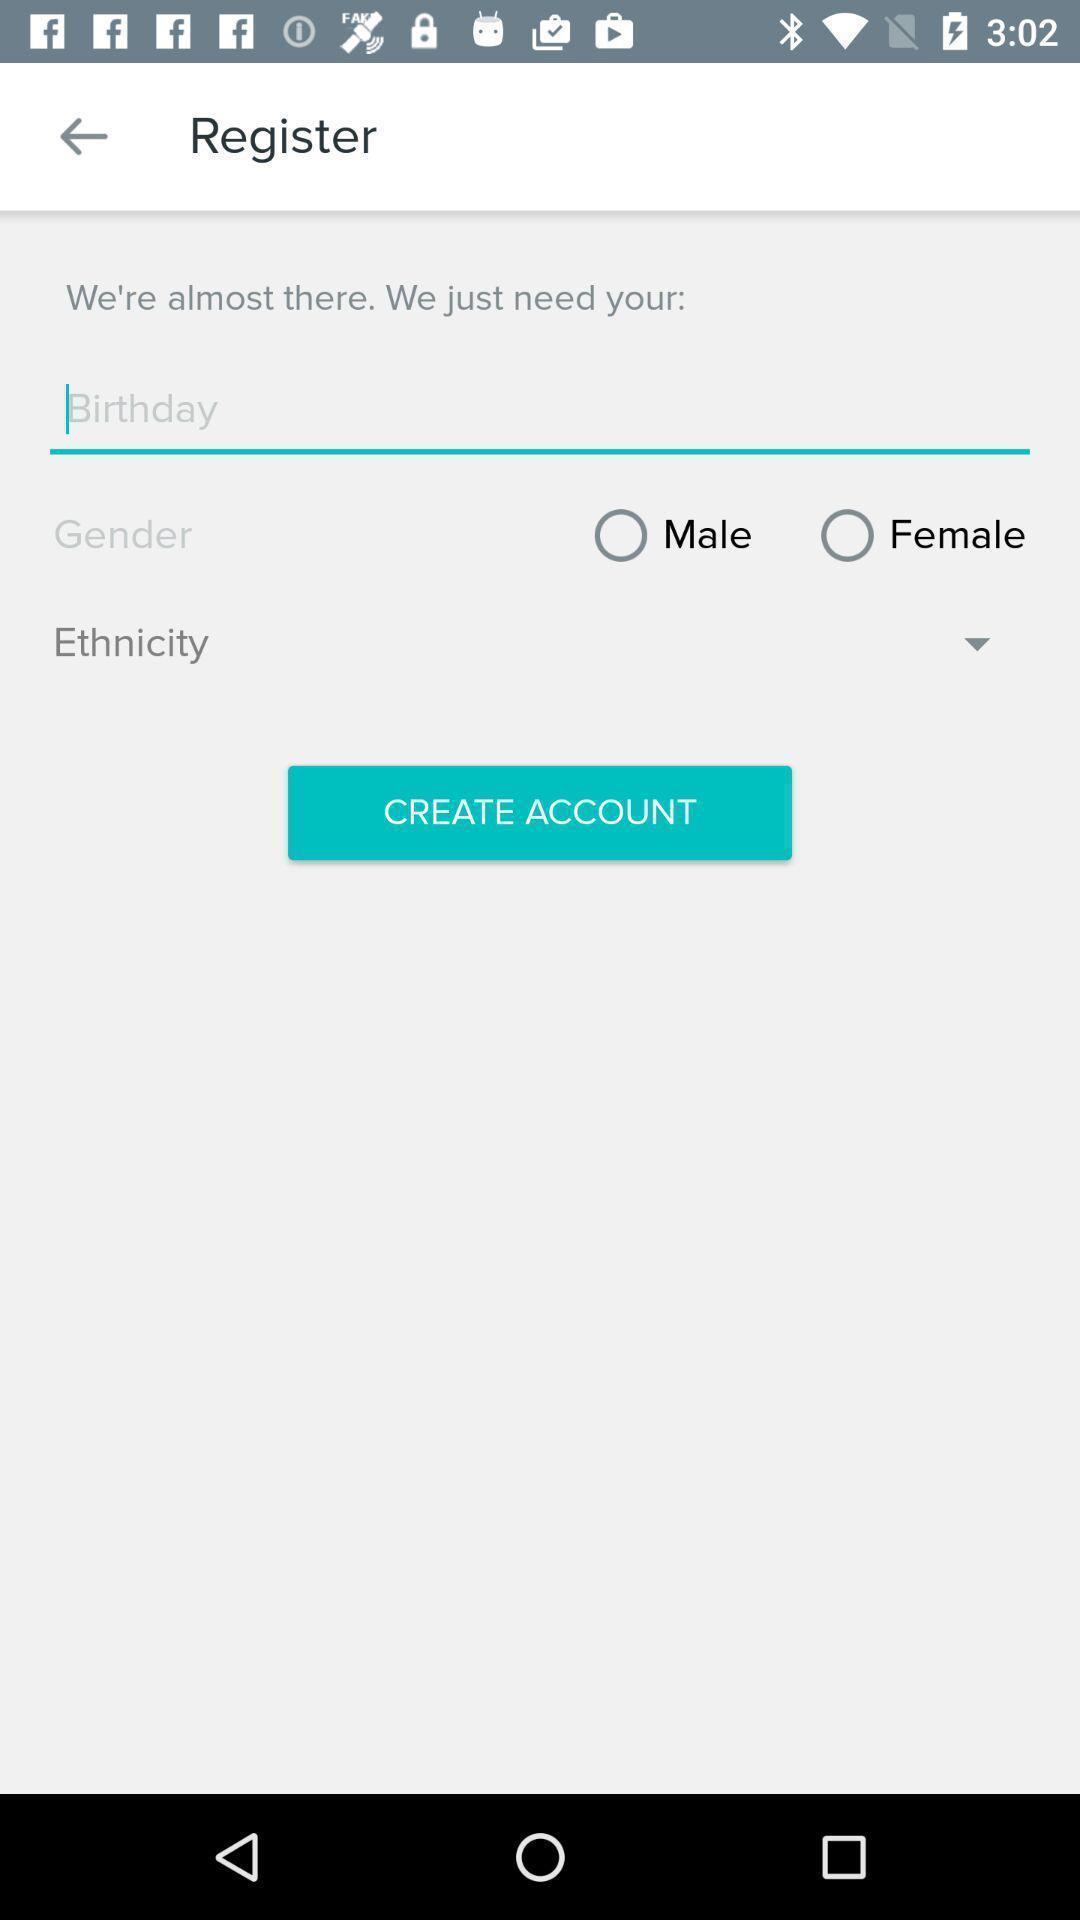Summarize the main components in this picture. Screen showing register page. 